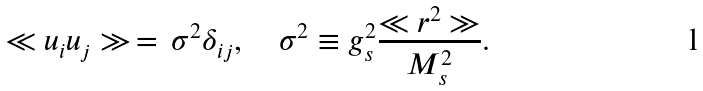Convert formula to latex. <formula><loc_0><loc_0><loc_500><loc_500>\ll u _ { i } u _ { j } \gg \, = \, \sigma ^ { 2 } \delta _ { i j } , \quad \sigma ^ { 2 } \equiv g _ { s } ^ { 2 } \frac { \ll r ^ { 2 } \gg } { M _ { s } ^ { 2 } } .</formula> 